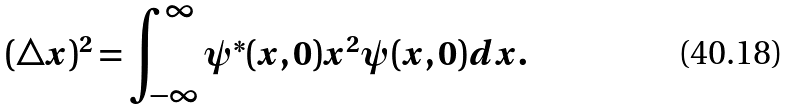<formula> <loc_0><loc_0><loc_500><loc_500>( \triangle x ) ^ { 2 } = \int _ { - \infty } ^ { \infty } \psi ^ { * } ( x , 0 ) x ^ { 2 } \psi ( x , 0 ) d x .</formula> 